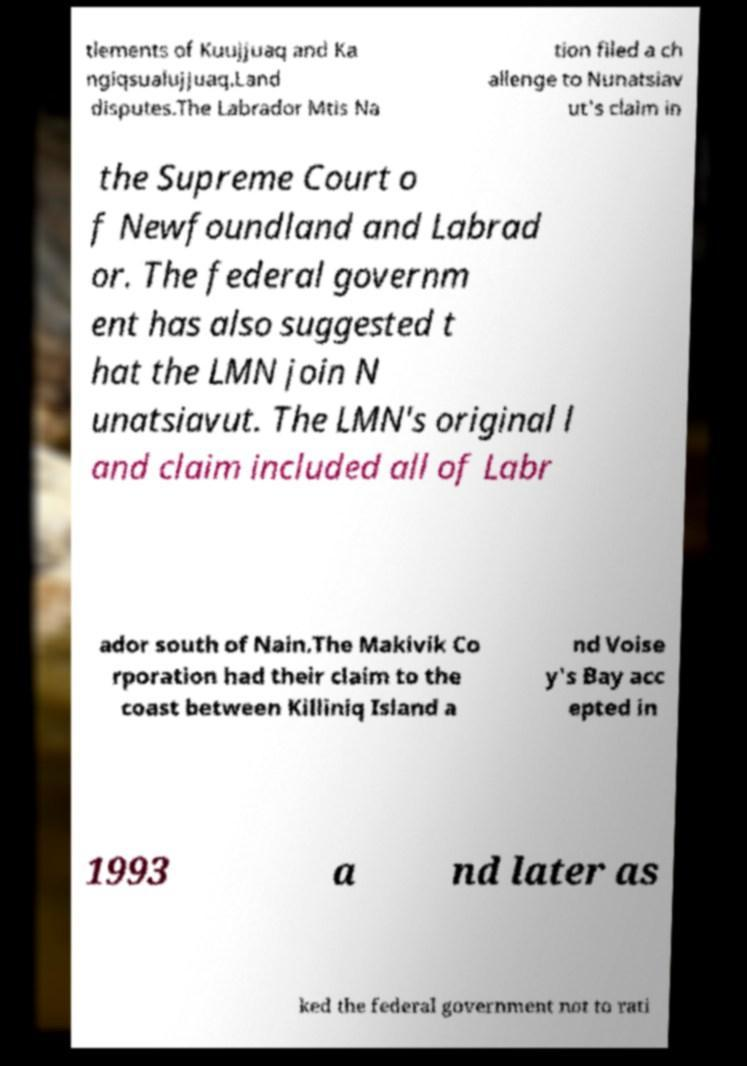What messages or text are displayed in this image? I need them in a readable, typed format. tlements of Kuujjuaq and Ka ngiqsualujjuaq.Land disputes.The Labrador Mtis Na tion filed a ch allenge to Nunatsiav ut's claim in the Supreme Court o f Newfoundland and Labrad or. The federal governm ent has also suggested t hat the LMN join N unatsiavut. The LMN's original l and claim included all of Labr ador south of Nain.The Makivik Co rporation had their claim to the coast between Killiniq Island a nd Voise y's Bay acc epted in 1993 a nd later as ked the federal government not to rati 